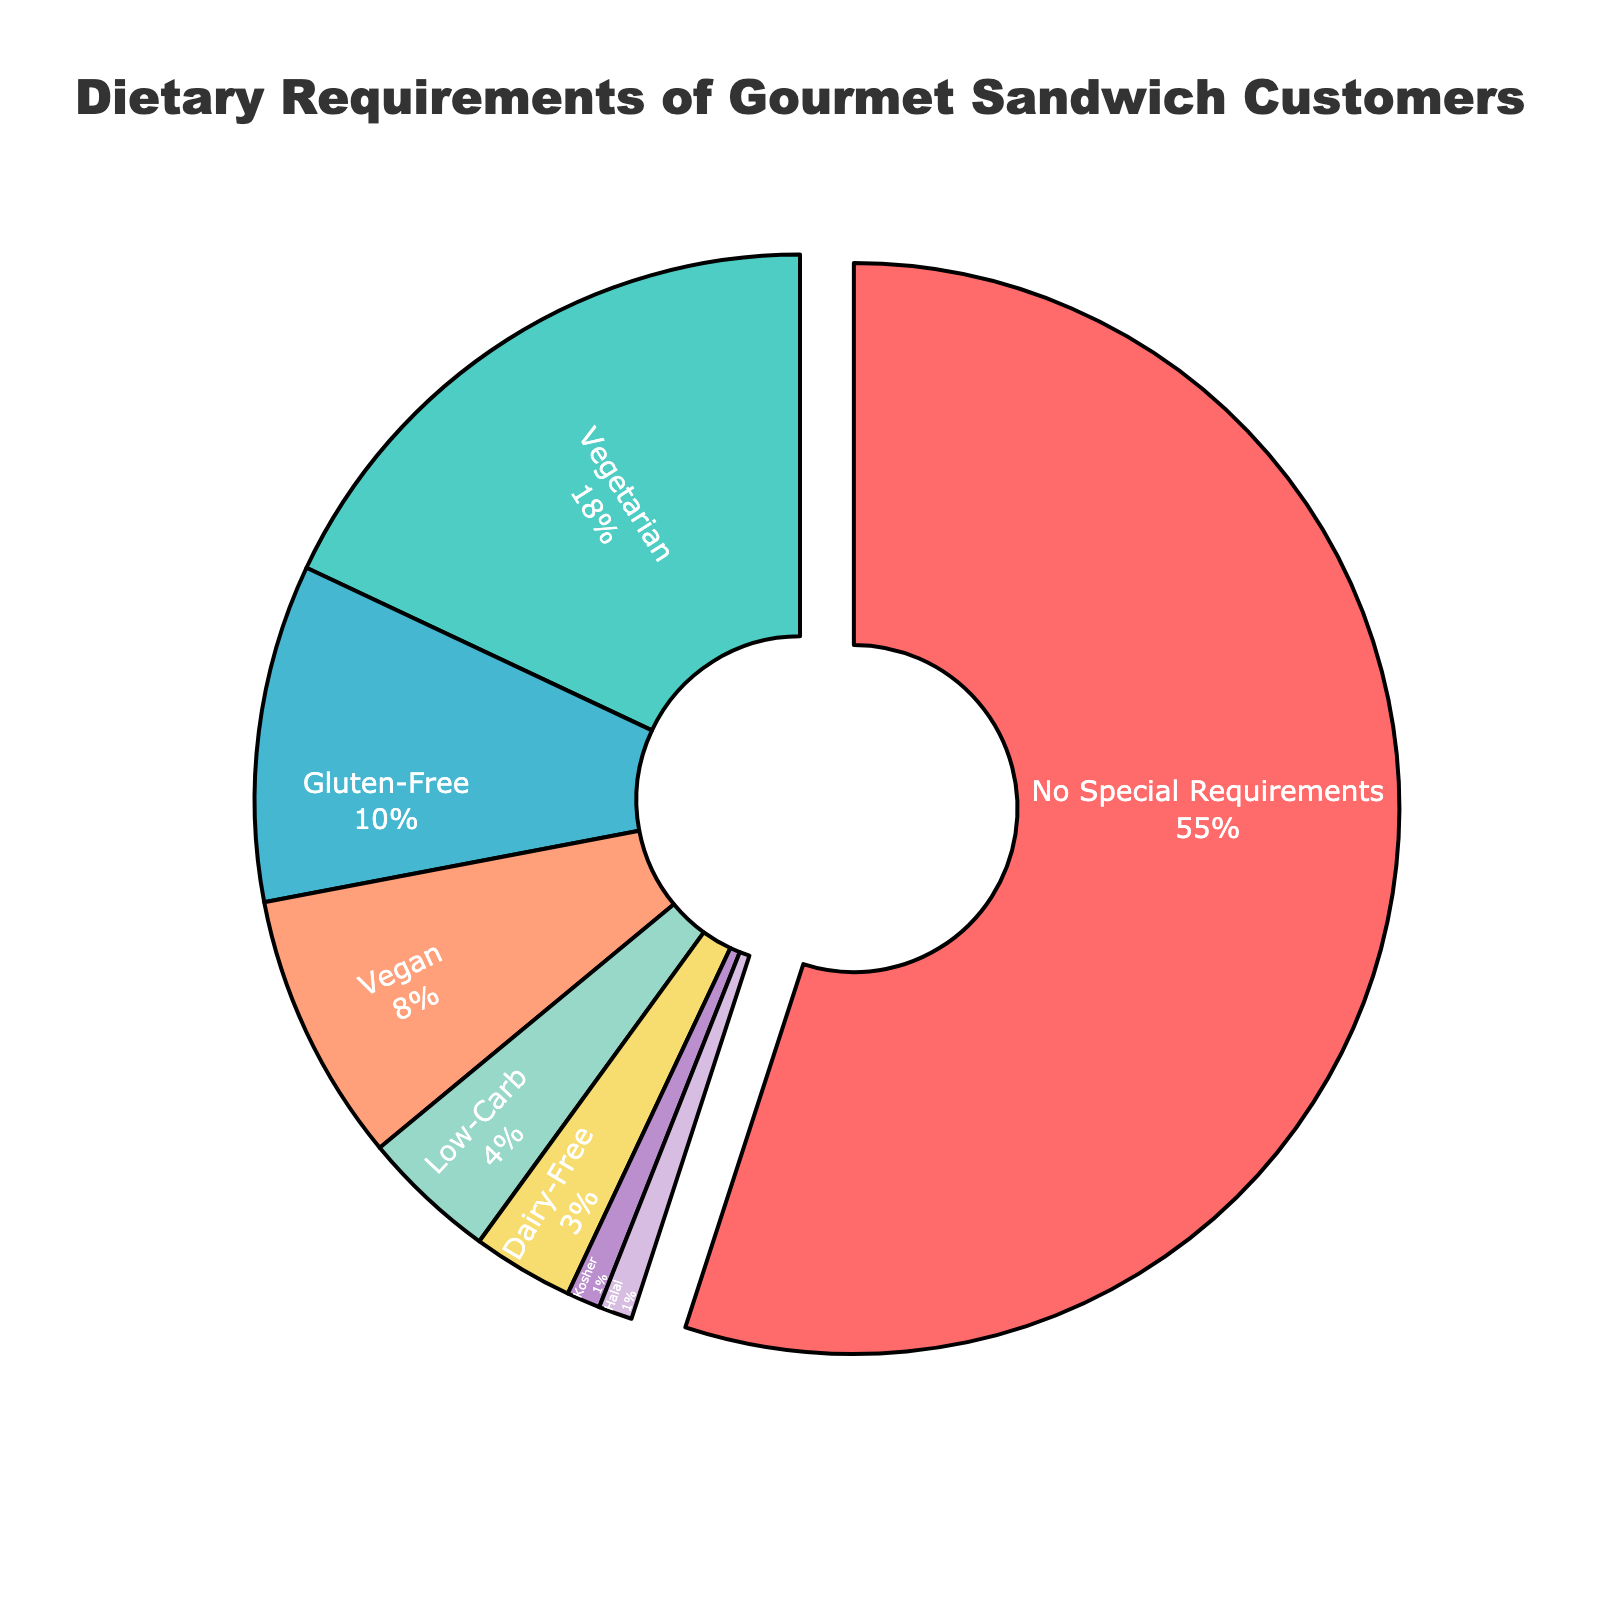what is the total percentage of customers with special dietary requirements? Add up all the percentages except for "No Special Requirements": 18 (Vegetarian) + 10 (Gluten-Free) + 8 (Vegan) + 4 (Low-Carb) + 3 (Dairy-Free) + 1 (Kosher) + 1 (Halal) = 45
Answer: 45 Which dietary requirement represents the smallest segment of your customers? The smallest segment is the one with the lowest percentage. Both "Kosher" and "Halal" have the smallest percentage at 1%.
Answer: Kosher and Halal How much larger is the "No Special Requirements" segment compared to the "Vegetarian" segment? Subtract the percentage of "Vegetarian" from "No Special Requirements": 55 (No Special Requirements) - 18 (Vegetarian) = 37%
Answer: 37 What is the combined percentage of customers who are either vegan or vegetarian? Add the percentages of "Vegan" and "Vegetarian": 8 (Vegan) + 18 (Vegetarian) = 26
Answer: 26 Which dietary requirement has the second-largest percentage? The second-largest percentage is "Vegetarian" with 18%, after "No Special Requirements".
Answer: Vegetarian If you combine all the special dietary requirements, which category comes closest to their total percentage? The total for special dietary requirements is 45%. "No Special Requirements" has 55%, which is closest.
Answer: No Special Requirements What color represents the "Gluten-Free" segment in the pie chart? The "Gluten-Free" segment is the third entry and is represented by the third color in the color list. The color order is ['#FF6B6B', '#4ECDC4', '#45B7D1', ...], so the third color is blue.
Answer: blue What percentage of customers follow a low-carb diet? Look at the segment labeled "Low-Carb" in the pie chart, which has a percentage of 4%.
Answer: 4 How many dietary requirements have a percentage higher than 5%? Count segments with percentages higher than 5%: "No Special Requirements" (55%), "Vegetarian" (18%), "Gluten-Free" (10%), and "Vegan" (8%). There are 4 such categories.
Answer: 4 What is the difference in percentage between the vegan and low-carb segments? Subtract the percentage of "Low-Carb" from "Vegan": 8 (Vegan) - 4 (Low-Carb) = 4
Answer: 4 